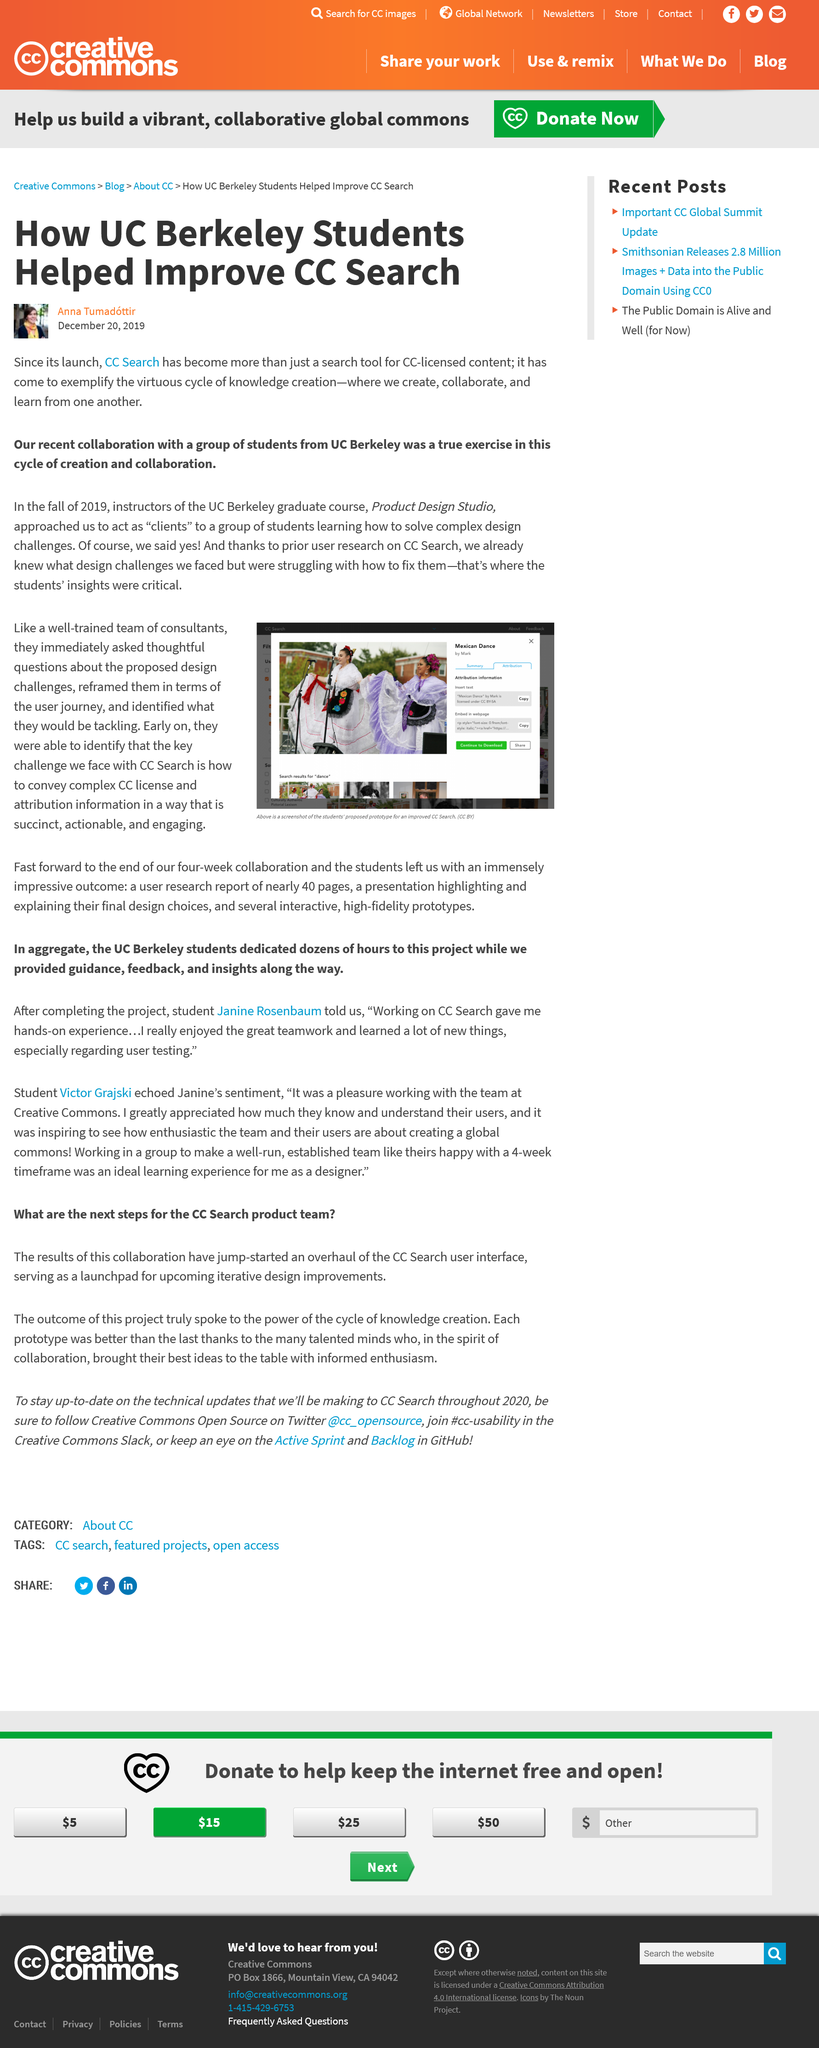Indicate a few pertinent items in this graphic. The article describes the efforts of UC Berkeley students who assisted in enhancing the search functionality of the California Digital Library (CDL). The questions were reframed in terms of the user journey. Yes, the challenge of conveying information in a succinct manner is a key challenge. The pictured dance is not an Alaskan dance, but rather a Mexican dance. The article was written by Anna Tumadottir. 